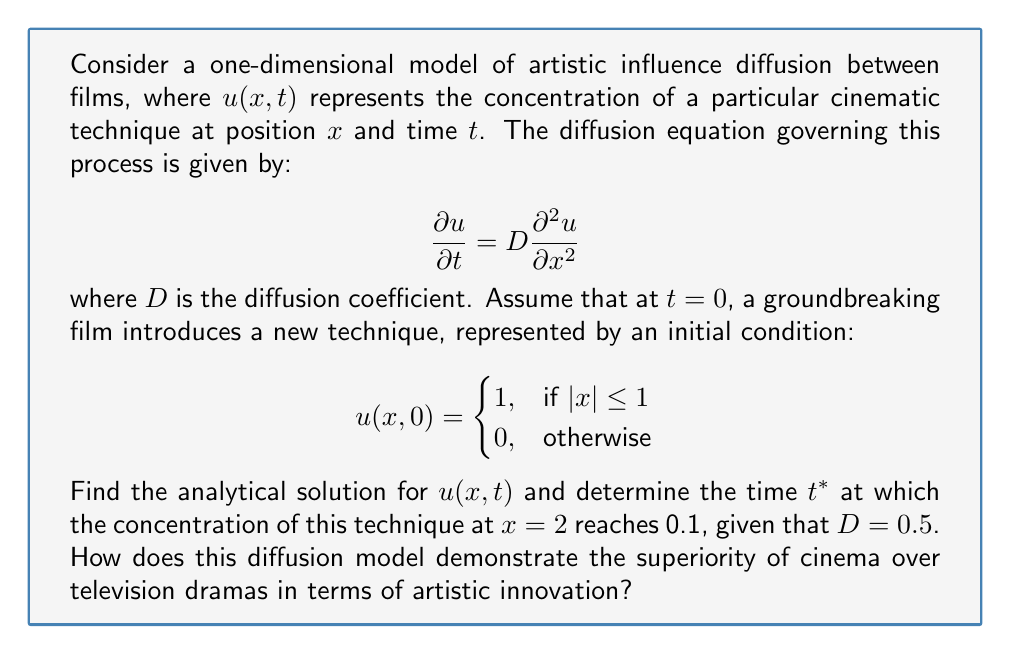Provide a solution to this math problem. To solve this problem, we need to follow these steps:

1) The given partial differential equation is the heat equation, which has a well-known solution for the given initial condition. The solution is:

   $$u(x,t) = \frac{1}{2}\left[\text{erf}\left(\frac{1-x}{\sqrt{4Dt}}\right) + \text{erf}\left(\frac{1+x}{\sqrt{4Dt}}\right)\right]$$

   where erf is the error function.

2) We're interested in the point $x=2$ and the time when $u(2,t) = 0.1$. Substituting these values:

   $$0.1 = \frac{1}{2}\left[\text{erf}\left(\frac{1-2}{\sqrt{2t}}\right) + \text{erf}\left(\frac{1+2}{\sqrt{2t}}\right)\right]$$

   $$0.2 = \text{erf}\left(\frac{-1}{\sqrt{2t}}\right) + \text{erf}\left(\frac{3}{\sqrt{2t}}\right)$$

3) This equation cannot be solved analytically. We need to use numerical methods or a computer algebra system to find $t^*$.

4) Using such methods, we find that $t^* \approx 2.954$.

5) Interpretation: This model shows how a cinematic technique, initially concentrated in a small region (representing a single groundbreaking film), spreads over time to influence other films. The time $t^*$ represents how long it takes for this influence to reach a significant level (0.1) at a distance of 2 units from the original source.

6) The relatively fast diffusion (reaching 0.1 concentration at $x=2$ in about 3 time units) demonstrates the efficiency of cinema in spreading artistic innovations. This model suggests that cinema, as a medium, allows for rapid dissemination of new techniques and ideas, supporting the notion of its artistic superiority over television dramas.
Answer: The time $t^*$ at which the concentration of the cinematic technique at $x=2$ reaches 0.1 is approximately 2.954 time units, given $D=0.5$. This rapid diffusion of artistic influence supports the argument for cinema's superiority over television dramas in terms of artistic innovation and impact. 